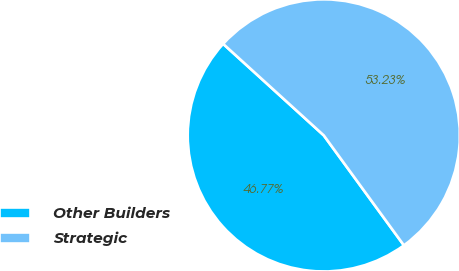<chart> <loc_0><loc_0><loc_500><loc_500><pie_chart><fcel>Other Builders<fcel>Strategic<nl><fcel>46.77%<fcel>53.23%<nl></chart> 